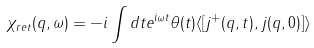Convert formula to latex. <formula><loc_0><loc_0><loc_500><loc_500>\chi _ { r e t } ( q , \omega ) = - i \int d t e ^ { i \omega t } \theta ( t ) \langle [ j ^ { + } ( q , t ) , j ( q , 0 ) ] \rangle</formula> 